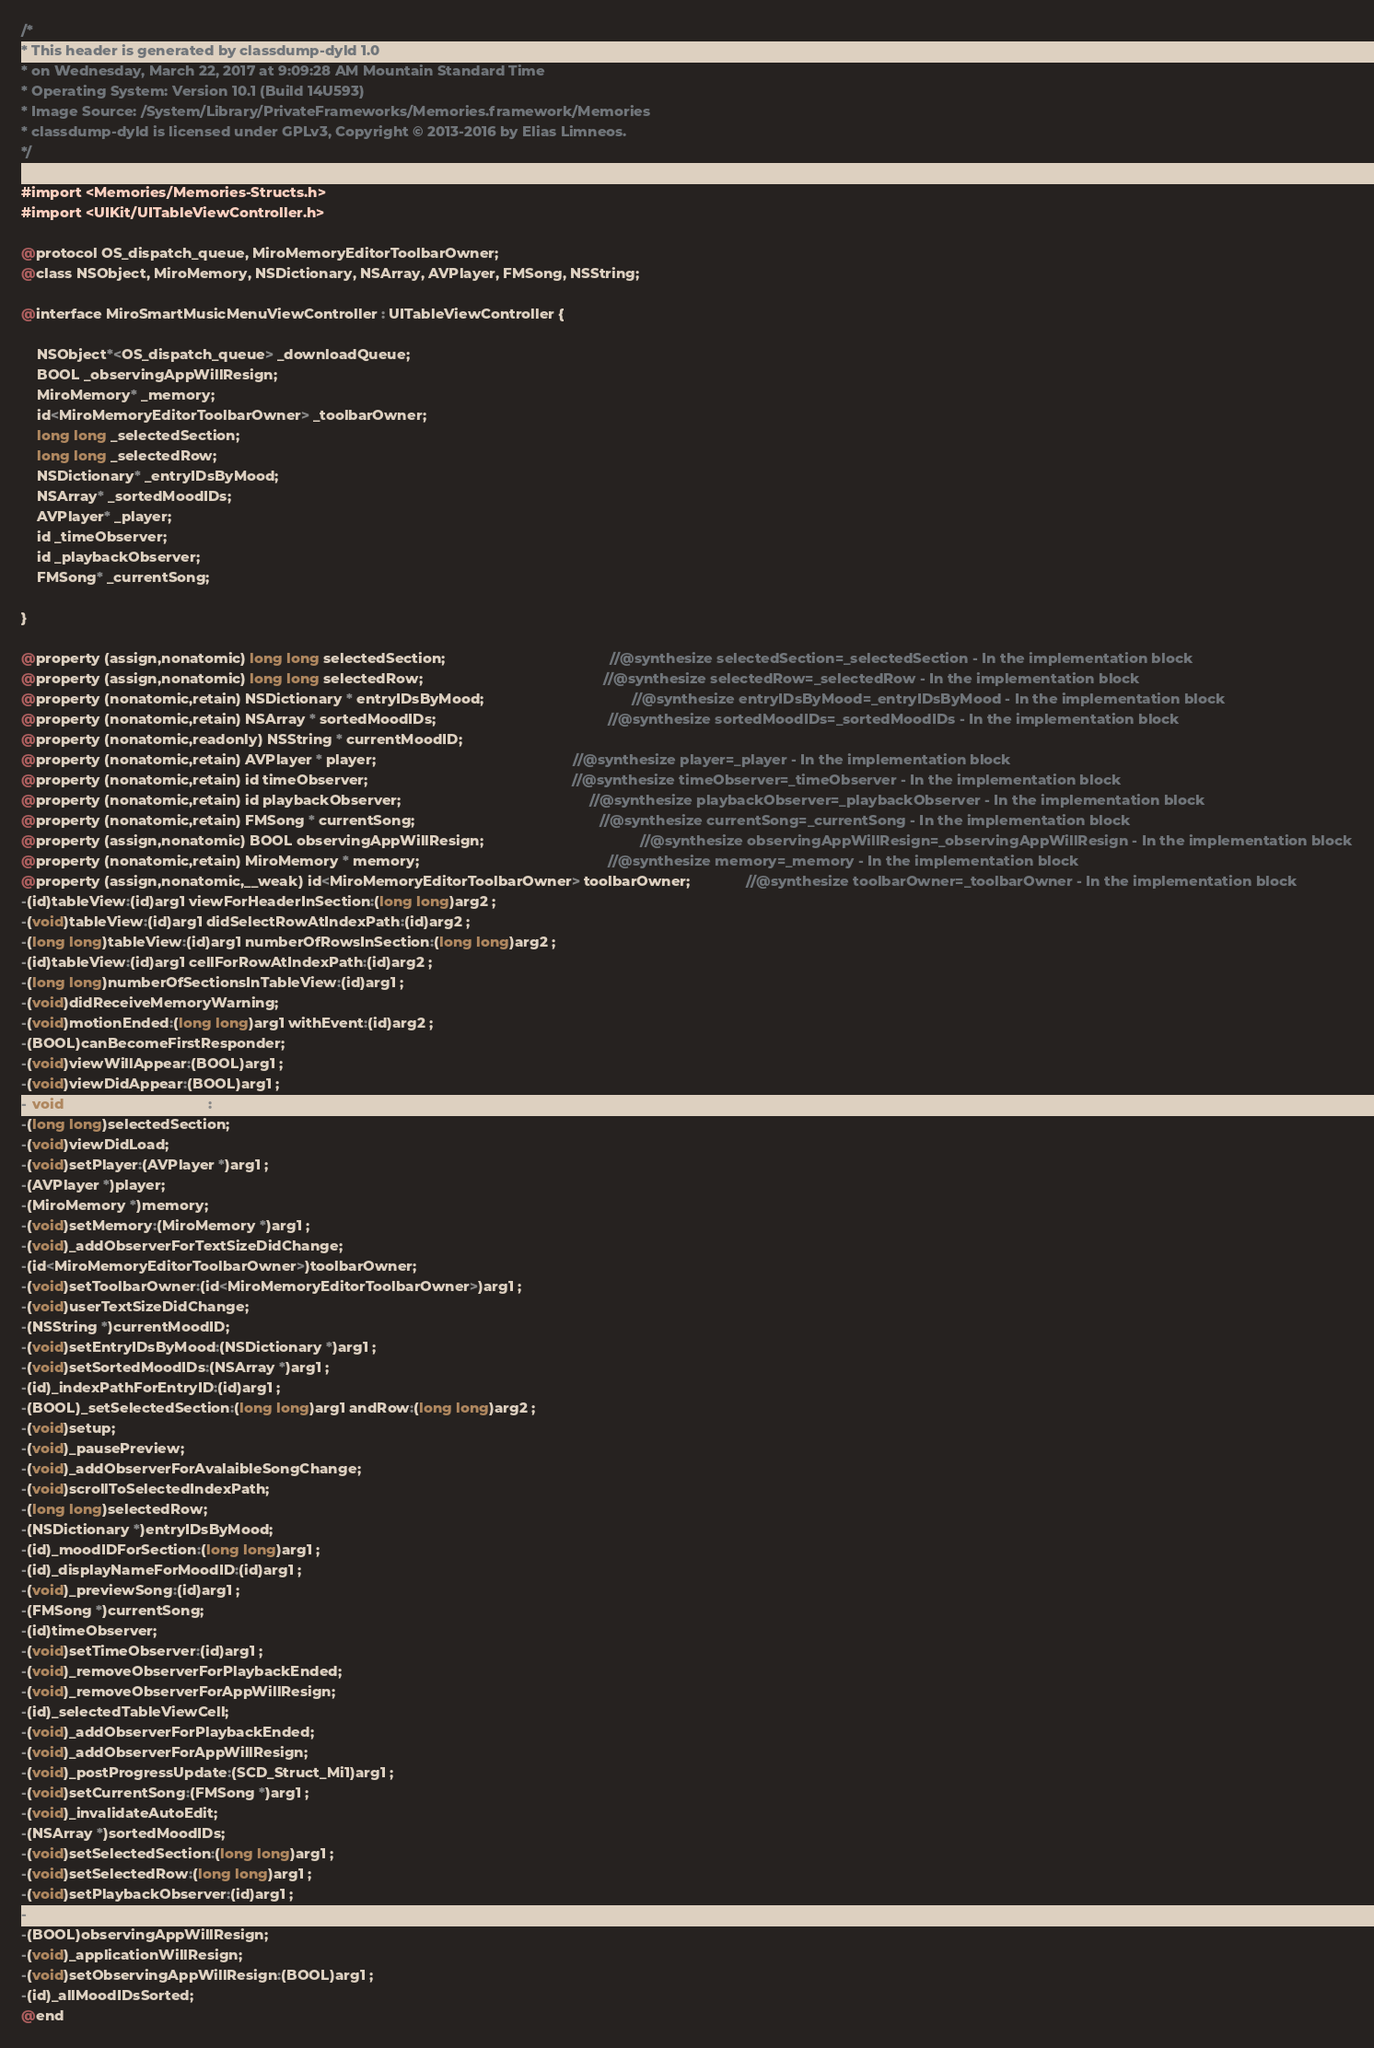<code> <loc_0><loc_0><loc_500><loc_500><_C_>/*
* This header is generated by classdump-dyld 1.0
* on Wednesday, March 22, 2017 at 9:09:28 AM Mountain Standard Time
* Operating System: Version 10.1 (Build 14U593)
* Image Source: /System/Library/PrivateFrameworks/Memories.framework/Memories
* classdump-dyld is licensed under GPLv3, Copyright © 2013-2016 by Elias Limneos.
*/

#import <Memories/Memories-Structs.h>
#import <UIKit/UITableViewController.h>

@protocol OS_dispatch_queue, MiroMemoryEditorToolbarOwner;
@class NSObject, MiroMemory, NSDictionary, NSArray, AVPlayer, FMSong, NSString;

@interface MiroSmartMusicMenuViewController : UITableViewController {

	NSObject*<OS_dispatch_queue> _downloadQueue;
	BOOL _observingAppWillResign;
	MiroMemory* _memory;
	id<MiroMemoryEditorToolbarOwner> _toolbarOwner;
	long long _selectedSection;
	long long _selectedRow;
	NSDictionary* _entryIDsByMood;
	NSArray* _sortedMoodIDs;
	AVPlayer* _player;
	id _timeObserver;
	id _playbackObserver;
	FMSong* _currentSong;

}

@property (assign,nonatomic) long long selectedSection;                                         //@synthesize selectedSection=_selectedSection - In the implementation block
@property (assign,nonatomic) long long selectedRow;                                             //@synthesize selectedRow=_selectedRow - In the implementation block
@property (nonatomic,retain) NSDictionary * entryIDsByMood;                                     //@synthesize entryIDsByMood=_entryIDsByMood - In the implementation block
@property (nonatomic,retain) NSArray * sortedMoodIDs;                                           //@synthesize sortedMoodIDs=_sortedMoodIDs - In the implementation block
@property (nonatomic,readonly) NSString * currentMoodID; 
@property (nonatomic,retain) AVPlayer * player;                                                 //@synthesize player=_player - In the implementation block
@property (nonatomic,retain) id timeObserver;                                                   //@synthesize timeObserver=_timeObserver - In the implementation block
@property (nonatomic,retain) id playbackObserver;                                               //@synthesize playbackObserver=_playbackObserver - In the implementation block
@property (nonatomic,retain) FMSong * currentSong;                                              //@synthesize currentSong=_currentSong - In the implementation block
@property (assign,nonatomic) BOOL observingAppWillResign;                                       //@synthesize observingAppWillResign=_observingAppWillResign - In the implementation block
@property (nonatomic,retain) MiroMemory * memory;                                               //@synthesize memory=_memory - In the implementation block
@property (assign,nonatomic,__weak) id<MiroMemoryEditorToolbarOwner> toolbarOwner;              //@synthesize toolbarOwner=_toolbarOwner - In the implementation block
-(id)tableView:(id)arg1 viewForHeaderInSection:(long long)arg2 ;
-(void)tableView:(id)arg1 didSelectRowAtIndexPath:(id)arg2 ;
-(long long)tableView:(id)arg1 numberOfRowsInSection:(long long)arg2 ;
-(id)tableView:(id)arg1 cellForRowAtIndexPath:(id)arg2 ;
-(long long)numberOfSectionsInTableView:(id)arg1 ;
-(void)didReceiveMemoryWarning;
-(void)motionEnded:(long long)arg1 withEvent:(id)arg2 ;
-(BOOL)canBecomeFirstResponder;
-(void)viewWillAppear:(BOOL)arg1 ;
-(void)viewDidAppear:(BOOL)arg1 ;
-(void)viewWillDisappear:(BOOL)arg1 ;
-(long long)selectedSection;
-(void)viewDidLoad;
-(void)setPlayer:(AVPlayer *)arg1 ;
-(AVPlayer *)player;
-(MiroMemory *)memory;
-(void)setMemory:(MiroMemory *)arg1 ;
-(void)_addObserverForTextSizeDidChange;
-(id<MiroMemoryEditorToolbarOwner>)toolbarOwner;
-(void)setToolbarOwner:(id<MiroMemoryEditorToolbarOwner>)arg1 ;
-(void)userTextSizeDidChange;
-(NSString *)currentMoodID;
-(void)setEntryIDsByMood:(NSDictionary *)arg1 ;
-(void)setSortedMoodIDs:(NSArray *)arg1 ;
-(id)_indexPathForEntryID:(id)arg1 ;
-(BOOL)_setSelectedSection:(long long)arg1 andRow:(long long)arg2 ;
-(void)setup;
-(void)_pausePreview;
-(void)_addObserverForAvalaibleSongChange;
-(void)scrollToSelectedIndexPath;
-(long long)selectedRow;
-(NSDictionary *)entryIDsByMood;
-(id)_moodIDForSection:(long long)arg1 ;
-(id)_displayNameForMoodID:(id)arg1 ;
-(void)_previewSong:(id)arg1 ;
-(FMSong *)currentSong;
-(id)timeObserver;
-(void)setTimeObserver:(id)arg1 ;
-(void)_removeObserverForPlaybackEnded;
-(void)_removeObserverForAppWillResign;
-(id)_selectedTableViewCell;
-(void)_addObserverForPlaybackEnded;
-(void)_addObserverForAppWillResign;
-(void)_postProgressUpdate:(SCD_Struct_Mi1)arg1 ;
-(void)setCurrentSong:(FMSong *)arg1 ;
-(void)_invalidateAutoEdit;
-(NSArray *)sortedMoodIDs;
-(void)setSelectedSection:(long long)arg1 ;
-(void)setSelectedRow:(long long)arg1 ;
-(void)setPlaybackObserver:(id)arg1 ;
-(id)playbackObserver;
-(BOOL)observingAppWillResign;
-(void)_applicationWillResign;
-(void)setObservingAppWillResign:(BOOL)arg1 ;
-(id)_allMoodIDsSorted;
@end

</code> 